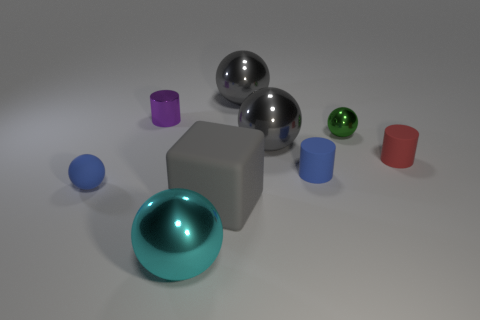Can you describe the lighting in this scene? The lighting in the scene appears to be soft and diffused, coming from above. There are subtle shadows under the objects, suggesting a singular light source that generates a calm and even illumination throughout. 